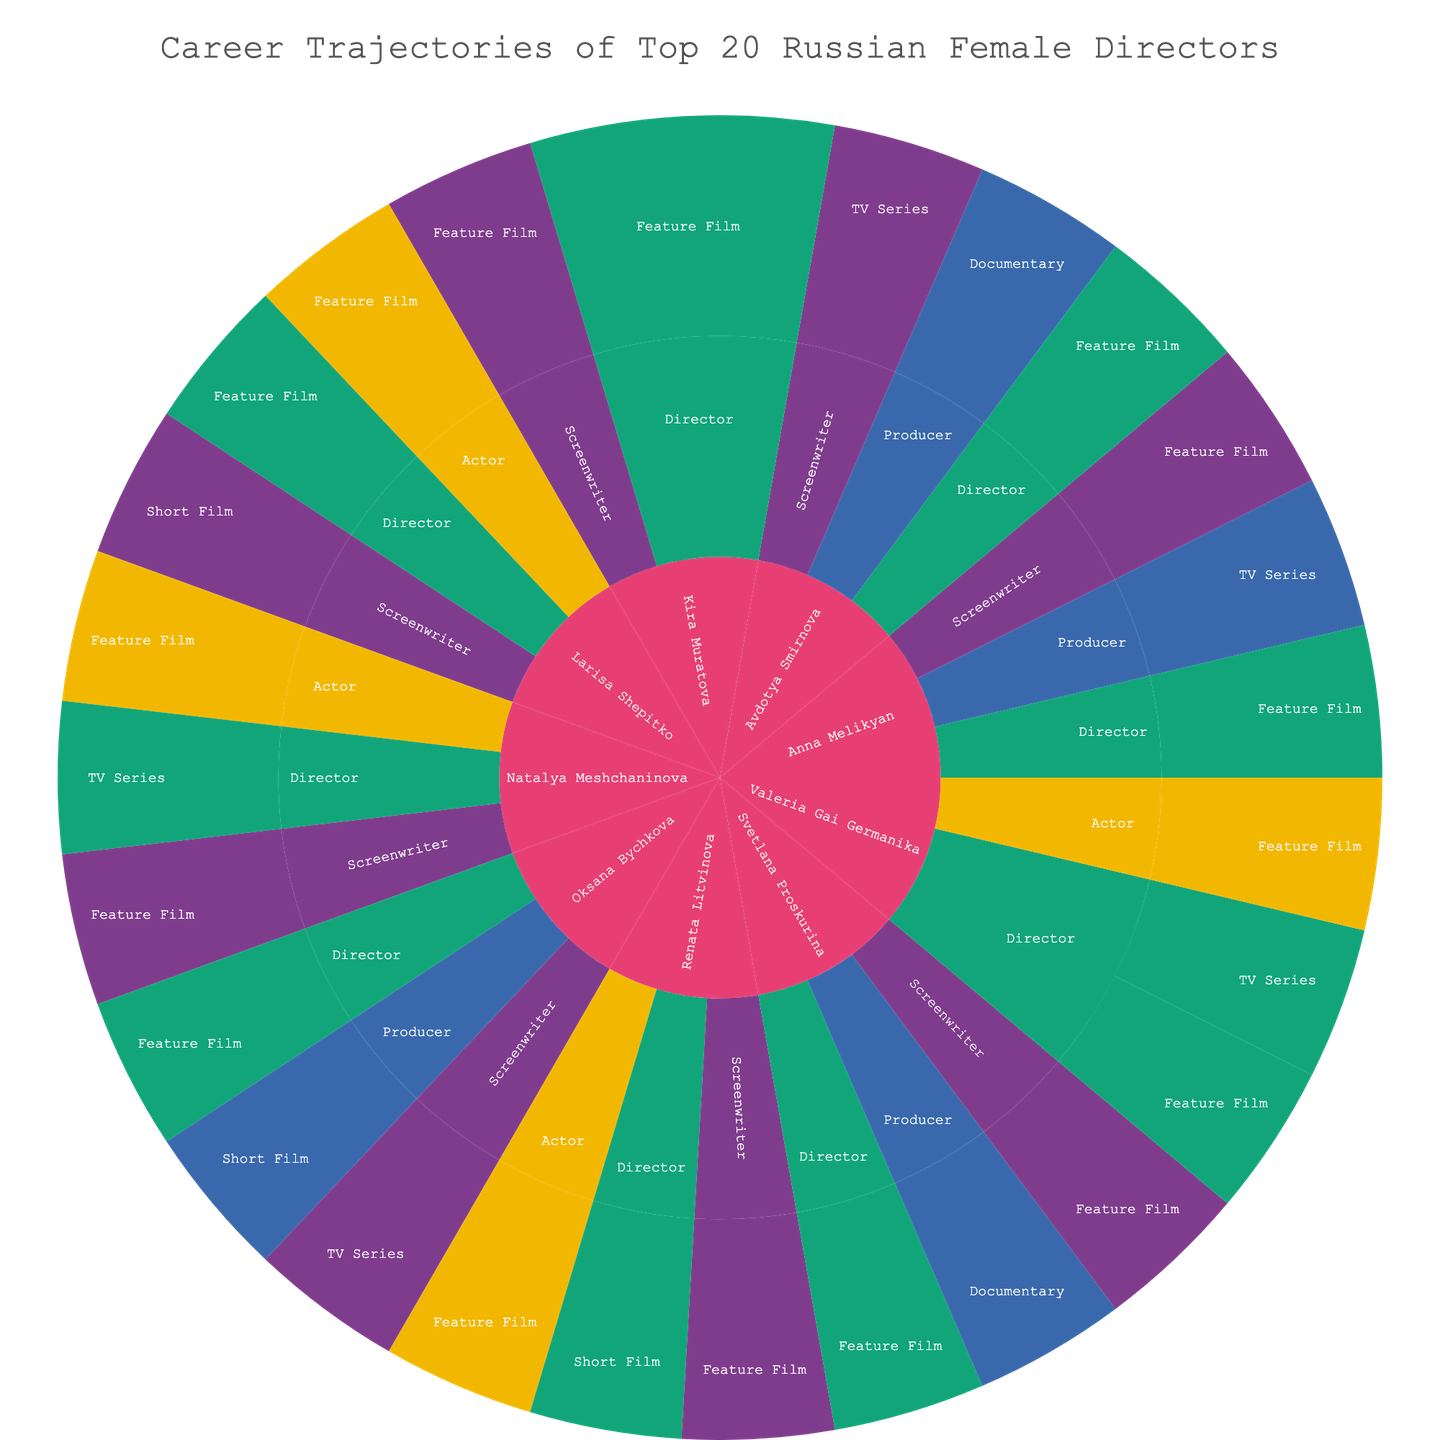What's the overall title of the figure? Look at the top section of the figure where the title is usually located.
Answer: Career Trajectories of Top 20 Russian Female Directors Which director has worked in the most diverse set of roles? Check the sunburst plot for the director who has segments branching out to the most variety of roles like Director, Screenwriter, Actor, and Producer.
Answer: Renata Litvinova How many feature films has Kira Muratova directed? Locate Kira Muratova's segment, then navigate to the directed films and count the segments specifically marked as Feature Films.
Answer: 2 How many different project types has Larisa Shepitko worked in? Find Larisa Shepitko in the center, then count the distinct segments branching out that signify different project types.
Answer: 2 Who directed the TV series "School"? Find the role "Director," then navigate to project type "TV Series" and look for "School."
Answer: Valeria Gai Germanika Which director has been involved in both short films and documentaries as a producer? Check the "Producer" segments for each director and see if they have both "Short Film" and "Documentary" listed under their name.
Answer: Svetlana Proskurina Which director has the most roles in TV series projects? Navigate each director's segments and count how many roles they have specifically in TV series projects, comparing to find the maximum.
Answer: Anna Melikyan How many directors have been actors in feature films? Locate the "Actor" roles for each director and count those who have segments explicitly marked as "Feature Film."
Answer: 4 Which director has worked as a screenwriter on feature films and also directed a short film? Look for directors who have segments for both "Screenwriter" in "Feature Film" and "Director" in "Short Film."
Answer: Renata Litvinova Which role has Avdotya Smirnova not taken on in comparison to Kira Muratova? Compare Avdotya Smirnova and Kira Muratova segments, identify roles taken on by Kira Muratova but not by Avdotya Smirnova.
Answer: Actor 